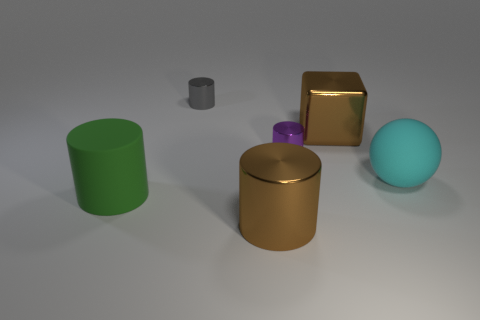Add 4 small red spheres. How many objects exist? 10 Subtract all blue cylinders. Subtract all brown spheres. How many cylinders are left? 4 Subtract all balls. How many objects are left? 5 Add 3 small brown things. How many small brown things exist? 3 Subtract 0 blue spheres. How many objects are left? 6 Subtract all gray metallic cylinders. Subtract all green things. How many objects are left? 4 Add 1 big cyan rubber things. How many big cyan rubber things are left? 2 